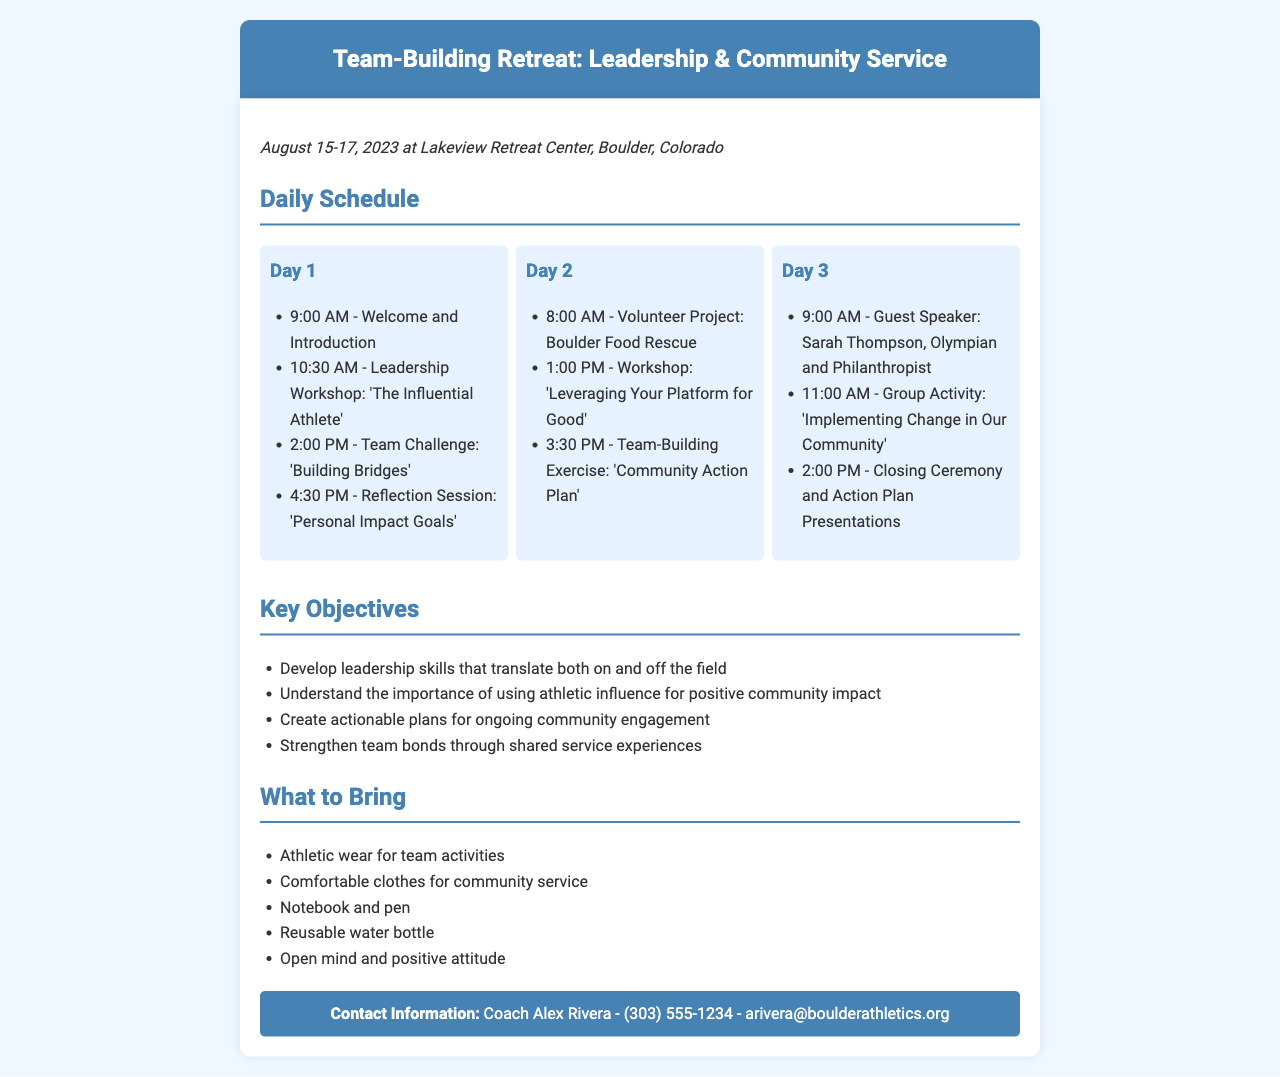what are the dates of the retreat? The dates of the retreat are clearly stated in the document, which is from August 15 to August 17, 2023.
Answer: August 15-17, 2023 where is the retreat located? The location of the retreat is specified in the document, indicating that it will be held at Lakeview Retreat Center, Boulder, Colorado.
Answer: Lakeview Retreat Center, Boulder, Colorado who is the guest speaker on Day 3? The document lists Sarah Thompson as the guest speaker for Day 3, which is mentioned under the schedule for that day.
Answer: Sarah Thompson what is one of the key objectives of the retreat? The document outlines several key objectives, one of which is to understand the importance of using athletic influence for positive community impact.
Answer: Use athletic influence for positive community impact what should participants bring to the retreat? The document provides a list of items participants are advised to bring, including athletic wear for team activities and a reusable water bottle.
Answer: Athletic wear, reusable water bottle what time does the welcome and introduction begin on Day 1? The specific time for the welcome and introduction is clearly stated in the schedule for Day 1, which starts at 9:00 AM.
Answer: 9:00 AM how many days does the retreat last? The document provides a clear start and end date for the retreat, indicating it lasts for three days.
Answer: Three days what type of project is scheduled for Day 2? The document specifies a volunteer project scheduled for Day 2, which is with Boulder Food Rescue.
Answer: Volunteer Project: Boulder Food Rescue 